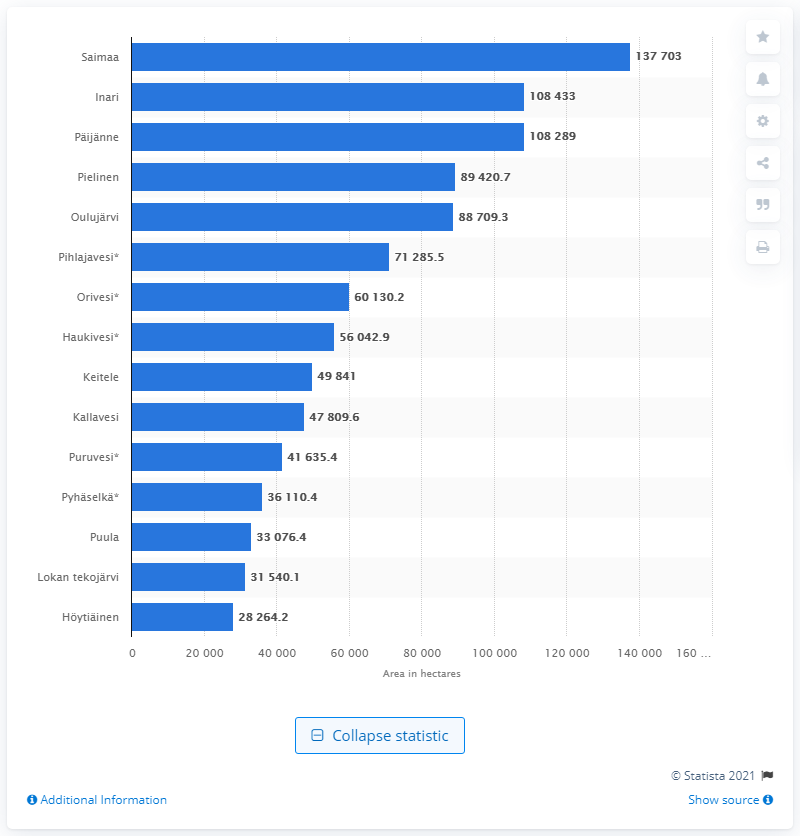Highlight a few significant elements in this photo. Saimaa is the largest lake in Finland. 